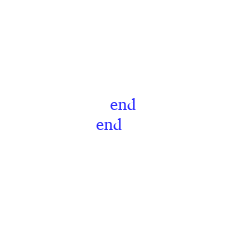<code> <loc_0><loc_0><loc_500><loc_500><_Ruby_>  end
end
</code> 